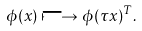Convert formula to latex. <formula><loc_0><loc_0><loc_500><loc_500>\phi ( x ) \longmapsto \phi ( \tau x ) ^ { T } .</formula> 